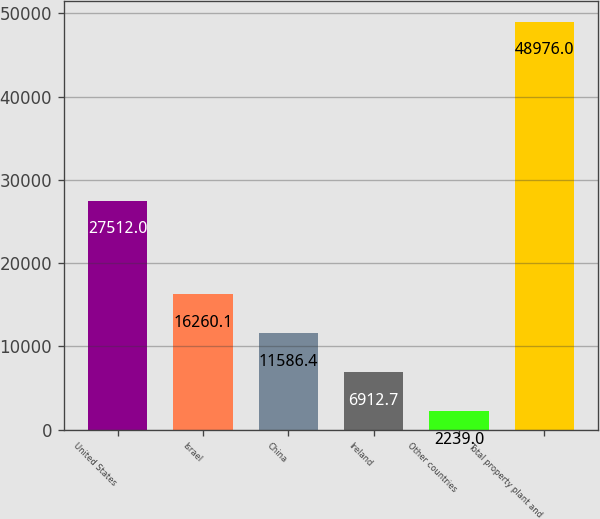Convert chart. <chart><loc_0><loc_0><loc_500><loc_500><bar_chart><fcel>United States<fcel>Israel<fcel>China<fcel>Ireland<fcel>Other countries<fcel>Total property plant and<nl><fcel>27512<fcel>16260.1<fcel>11586.4<fcel>6912.7<fcel>2239<fcel>48976<nl></chart> 